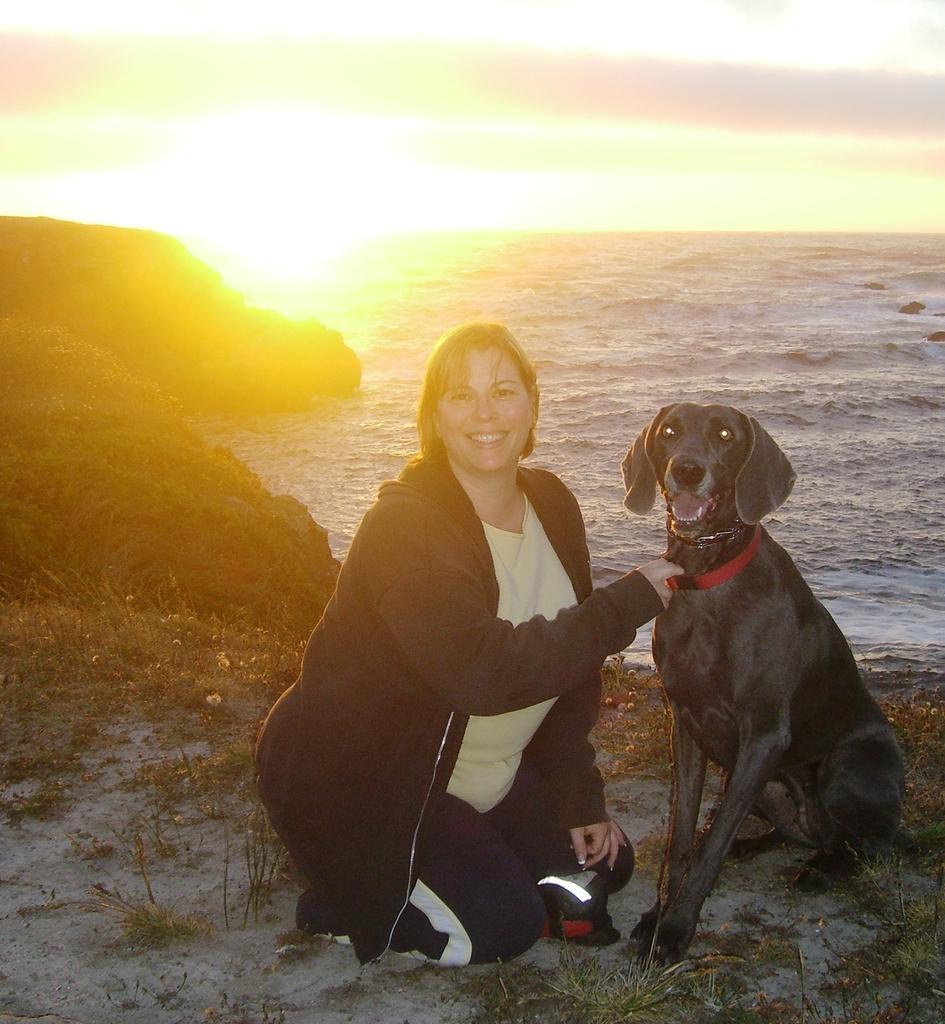In one or two sentences, can you explain what this image depicts? This picture is clicked outside the city. In front of the picture, we see woman in black jacket is in squad position and she is smiling. Beside her, we see a dog in black color and it has red belt around its neck and she is holding the belt. Behind them, we see a water in lake or river. To the left the corner of the picture, we see shrubs and behind that, we see sun. 